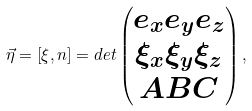Convert formula to latex. <formula><loc_0><loc_0><loc_500><loc_500>\vec { \eta } = \left [ \xi , n \right ] = d e t \begin{pmatrix} e _ { x } e _ { y } e _ { z } \\ \xi _ { x } \xi _ { y } \xi _ { z } \\ A B C \end{pmatrix} ,</formula> 